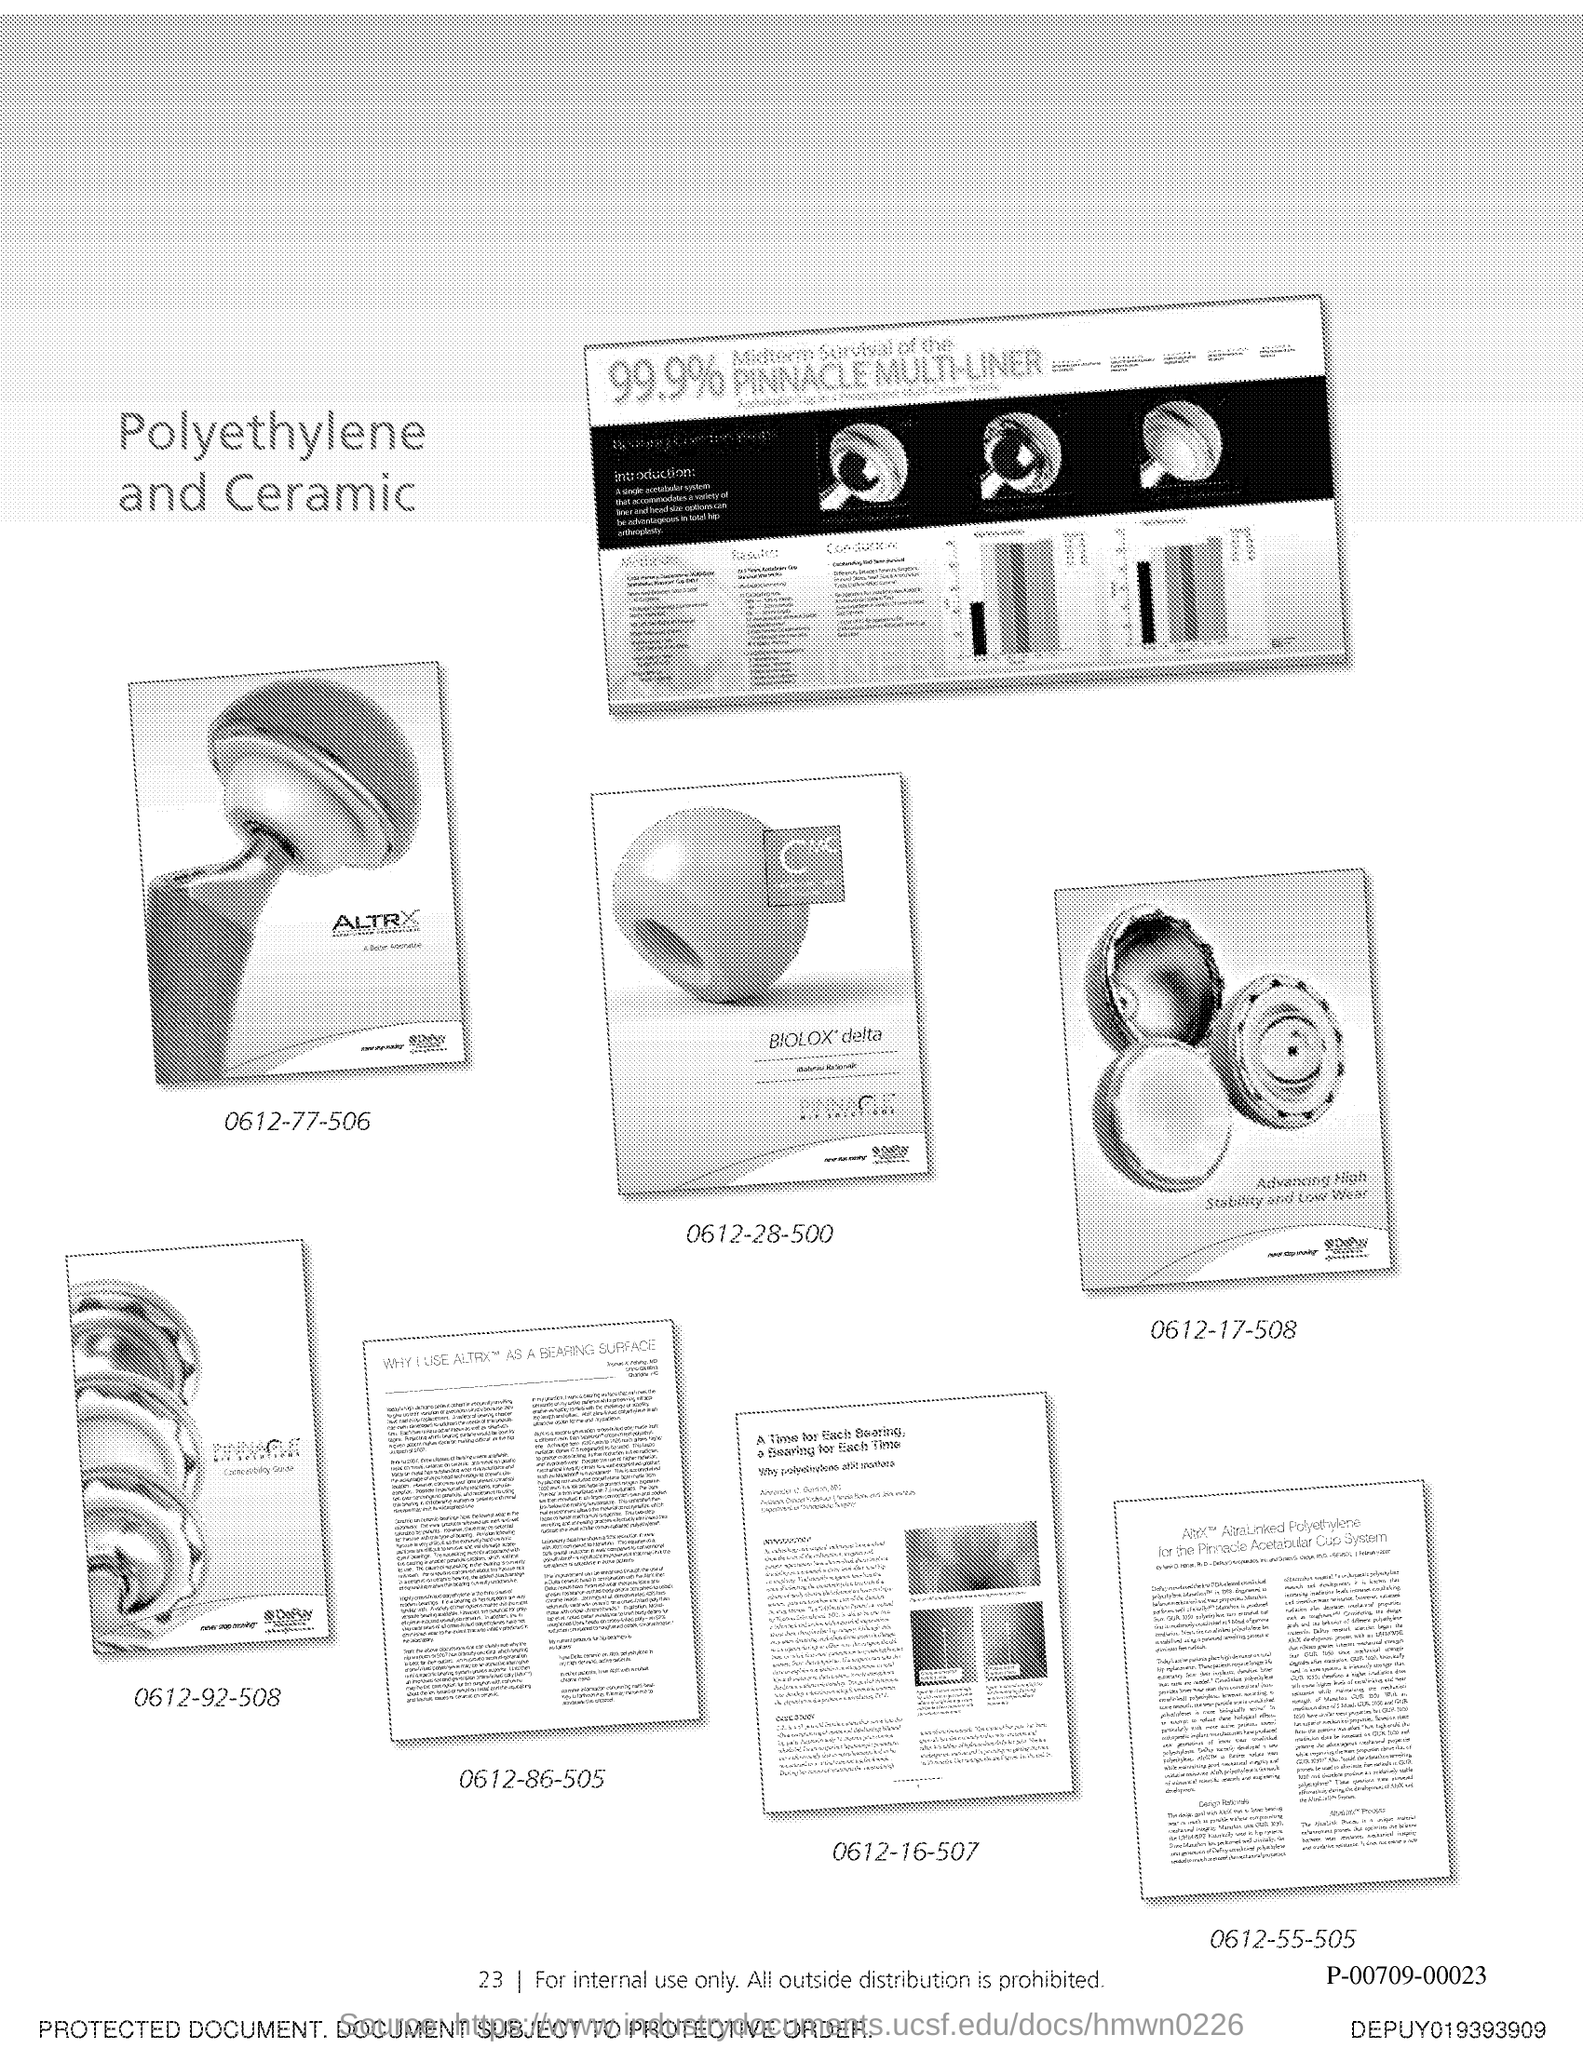What is the Page Number?
Give a very brief answer. 23. 